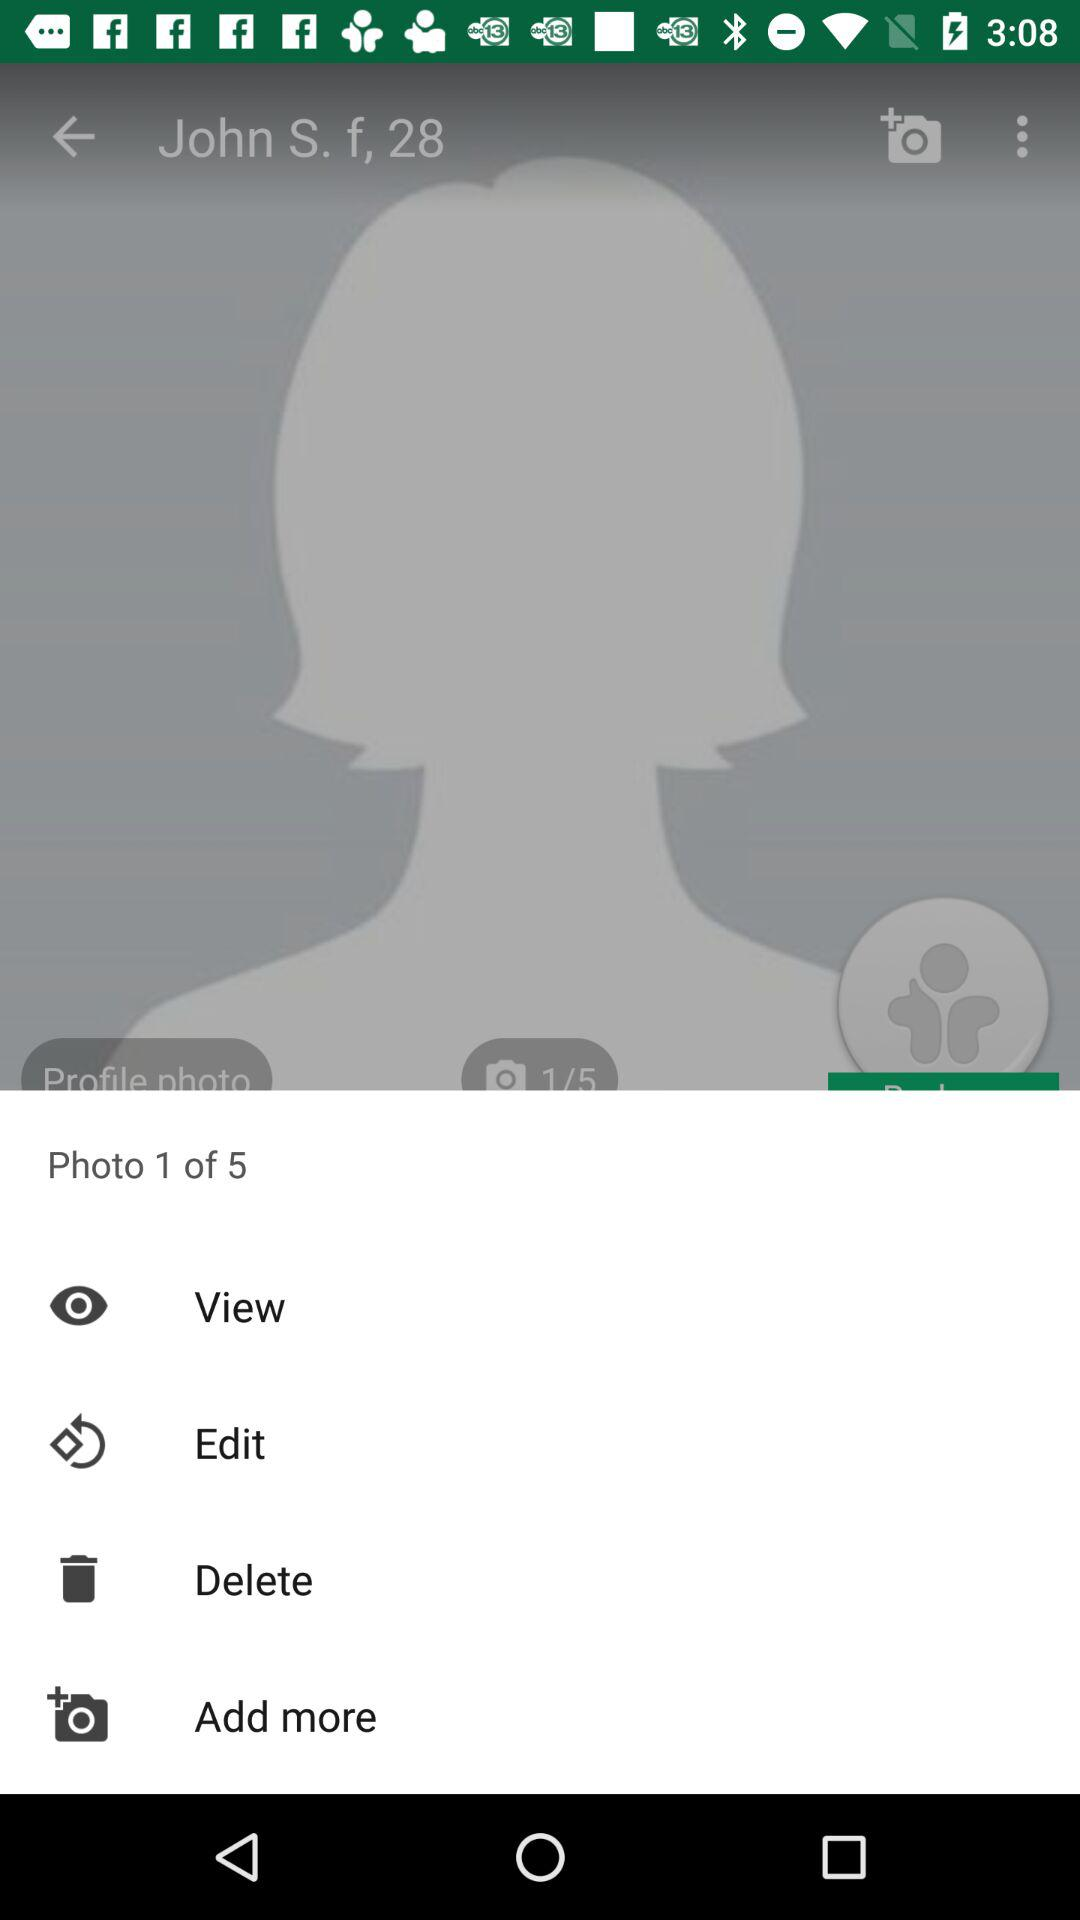How many total photos are there? There are 5 photos. 